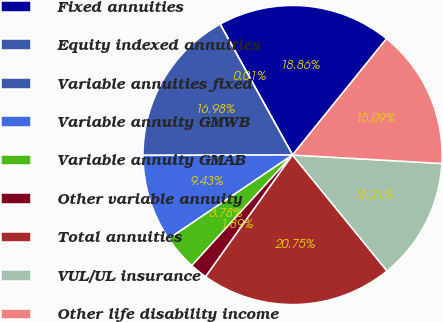Convert chart. <chart><loc_0><loc_0><loc_500><loc_500><pie_chart><fcel>Fixed annuities<fcel>Equity indexed annuities<fcel>Variable annuities fixed<fcel>Variable annuity GMWB<fcel>Variable annuity GMAB<fcel>Other variable annuity<fcel>Total annuities<fcel>VUL/UL insurance<fcel>Other life disability income<nl><fcel>18.86%<fcel>0.01%<fcel>16.98%<fcel>9.43%<fcel>3.78%<fcel>1.89%<fcel>20.75%<fcel>13.21%<fcel>15.09%<nl></chart> 